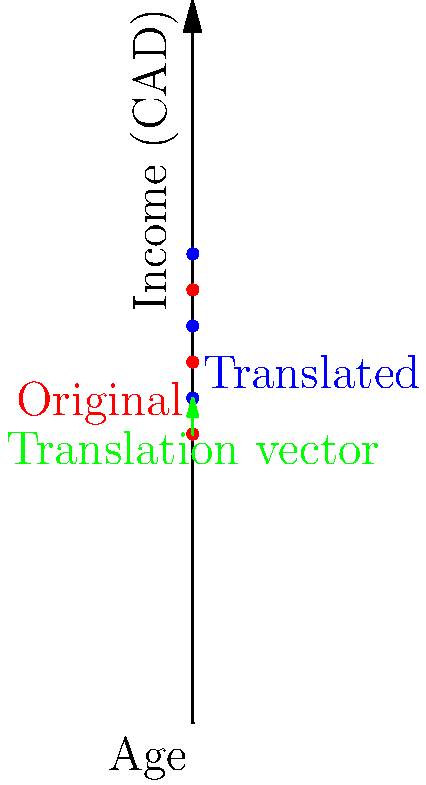A sociological study in Canada plots the relationship between age and income for a sample population. The original data points (in red) represent (age, income) pairs: (30, 40000), (40, 50000), and (50, 60000). If these points undergo a translation of 5 years in age and $5000 in income, what is the vector of translation, and what are the coordinates of the new points (in blue)? To solve this problem, we need to follow these steps:

1. Identify the translation:
   - Age increases by 5 years
   - Income increases by $5000

2. Express the translation as a vector:
   The translation vector is $(5, 5000)$

3. Apply the translation to each original point:
   - Point 1: $(30, 40000) + (5, 5000) = (35, 45000)$
   - Point 2: $(40, 50000) + (5, 5000) = (45, 55000)$
   - Point 3: $(50, 60000) + (5, 5000) = (55, 65000)$

4. Verify the new coordinates on the graph:
   The blue points represent the translated data points, which match our calculations.

5. Summarize the results:
   - Translation vector: $(5, 5000)$
   - New coordinates: $(35, 45000)$, $(45, 55000)$, $(55, 65000)$
Answer: Translation vector: $(5, 5000)$; New coordinates: $(35, 45000)$, $(45, 55000)$, $(55, 65000)$ 